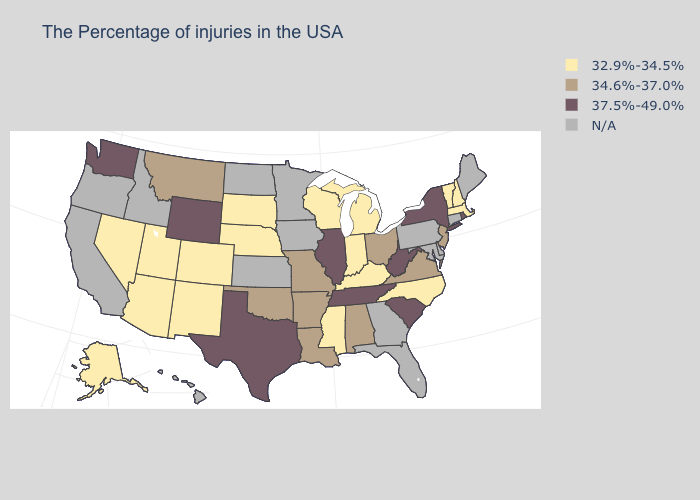What is the value of Alabama?
Quick response, please. 34.6%-37.0%. How many symbols are there in the legend?
Give a very brief answer. 4. Does Vermont have the lowest value in the Northeast?
Write a very short answer. Yes. What is the value of South Carolina?
Quick response, please. 37.5%-49.0%. Among the states that border New Mexico , which have the highest value?
Answer briefly. Texas. Name the states that have a value in the range N/A?
Be succinct. Maine, Connecticut, Delaware, Maryland, Pennsylvania, Florida, Georgia, Minnesota, Iowa, Kansas, North Dakota, Idaho, California, Oregon, Hawaii. What is the value of Louisiana?
Answer briefly. 34.6%-37.0%. What is the value of Maryland?
Quick response, please. N/A. What is the lowest value in states that border Connecticut?
Be succinct. 32.9%-34.5%. What is the value of Nebraska?
Quick response, please. 32.9%-34.5%. What is the value of Alaska?
Answer briefly. 32.9%-34.5%. Name the states that have a value in the range 34.6%-37.0%?
Keep it brief. New Jersey, Virginia, Ohio, Alabama, Louisiana, Missouri, Arkansas, Oklahoma, Montana. What is the value of Maine?
Be succinct. N/A. What is the lowest value in the USA?
Keep it brief. 32.9%-34.5%. 